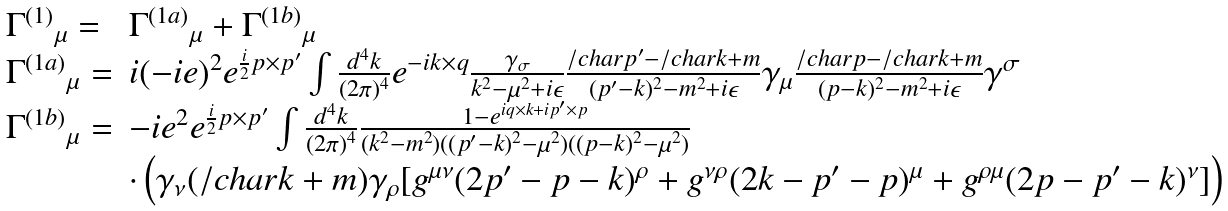Convert formula to latex. <formula><loc_0><loc_0><loc_500><loc_500>\begin{array} { l l } { \Gamma ^ { ( 1 ) } } _ { \mu } = & { \Gamma ^ { ( 1 a ) } } _ { \mu } + { \Gamma ^ { ( 1 b ) } } _ { \mu } \\ { \Gamma ^ { ( 1 a ) } } _ { \mu } = & i ( - i e ) ^ { 2 } e ^ { \frac { i } { 2 } p \times p ^ { \prime } } \int { \frac { d ^ { 4 } k } { ( 2 \pi ) ^ { 4 } } e ^ { - i k \times q } \frac { \gamma _ { \sigma } } { k ^ { 2 } - \mu ^ { 2 } + i \epsilon } \frac { \slash c h a r { p } ^ { \prime } - \slash c h a r { k } + m } { ( p ^ { \prime } - k ) ^ { 2 } - m ^ { 2 } + i \epsilon } \gamma _ { \mu } \frac { \slash c h a r { p } - \slash c h a r { k } + m } { ( p - k ) ^ { 2 } - m ^ { 2 } + i \epsilon } \gamma ^ { \sigma } } \\ { \Gamma ^ { ( 1 b ) } } _ { \mu } = & - i e ^ { 2 } e ^ { \frac { i } { 2 } p \times p ^ { \prime } } \int \frac { d ^ { 4 } k } { ( 2 \pi ) ^ { 4 } } \frac { 1 - e ^ { i q \times k + i p ^ { \prime } \times p } } { ( k ^ { 2 } - m ^ { 2 } ) ( ( p ^ { \prime } - k ) ^ { 2 } - \mu ^ { 2 } ) ( ( p - k ) ^ { 2 } - \mu ^ { 2 } ) } \\ & \cdot \left ( \gamma _ { \nu } ( \slash c h a r { k } + m ) \gamma _ { \rho } [ g ^ { \mu \nu } ( 2 p ^ { \prime } - p - k ) ^ { \rho } + g ^ { \nu \rho } ( 2 k - p ^ { \prime } - p ) ^ { \mu } + g ^ { \rho \mu } ( 2 p - p ^ { \prime } - k ) ^ { \nu } ] \right ) \\ \end{array}</formula> 